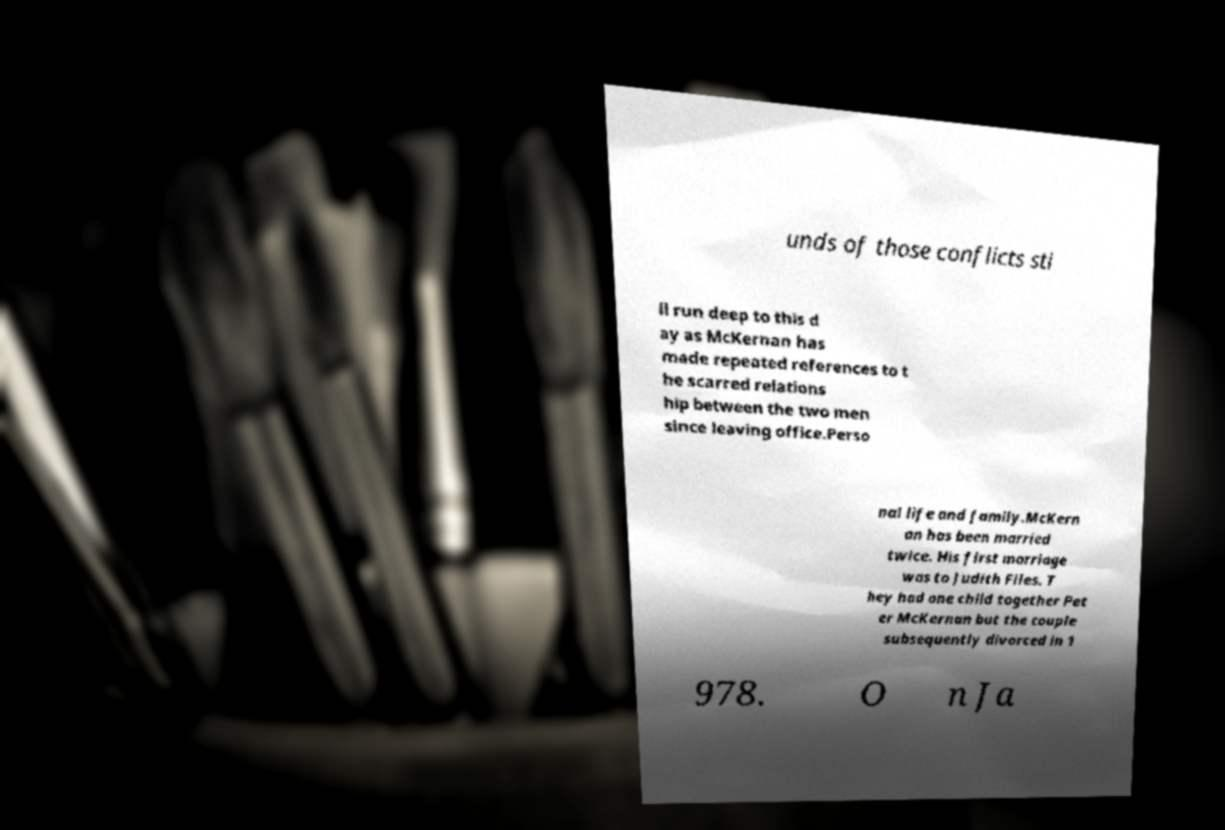Could you assist in decoding the text presented in this image and type it out clearly? unds of those conflicts sti ll run deep to this d ay as McKernan has made repeated references to t he scarred relations hip between the two men since leaving office.Perso nal life and family.McKern an has been married twice. His first marriage was to Judith Files. T hey had one child together Pet er McKernan but the couple subsequently divorced in 1 978. O n Ja 